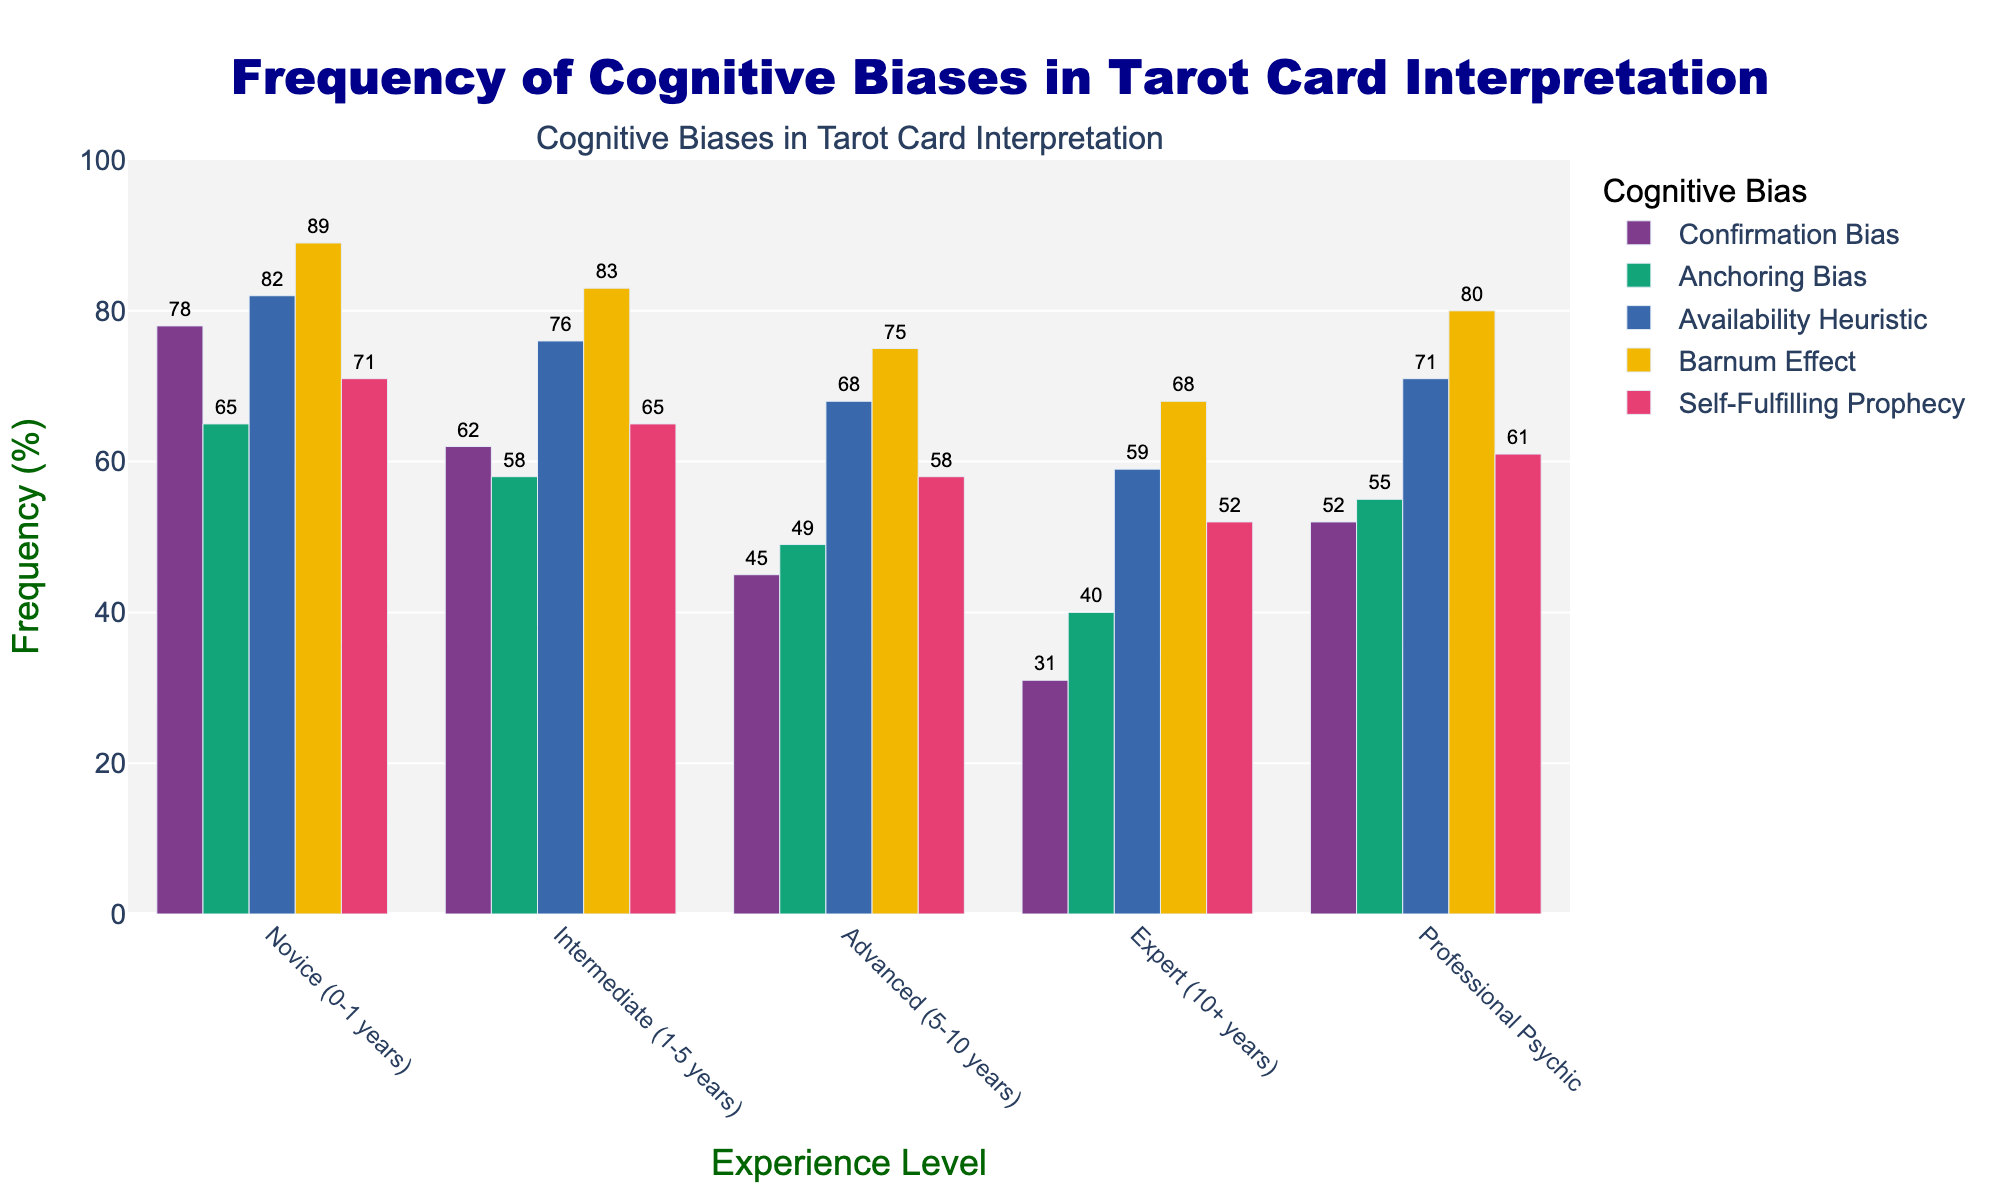Which experience level shows the highest frequency of the Barnum Effect? The height of the bars indicates the frequency; the Barnum Effect has the highest frequency bar for the "Novice (0-1 years)" group.
Answer: Novice (0-1 years) Which cognitive bias shows a decrease in frequency as the experience level of readers increases? By observing trends from Novice to Expert, all cognitive biases show a decrease. However, the decrease is most noticeable for Confirmation Bias and the Barnum Effect.
Answer: Confirmation Bias and Barnum Effect How much less frequent is the Anchoring Bias in Expert readers compared to Novice readers? Anchoring Bias frequency in Novice readers is 65 and in Expert readers is 40. The difference is 65 - 40.
Answer: 25 Which bias has the least variation in frequency across the different experience levels? By visually comparing the heights of the bars for each bias across experience levels, the Barnum Effect shows the smallest variance.
Answer: Barnum Effect What is the average frequency of the Availability Heuristic for all experience levels? Sum frequencies: (82+76+68+59+71)=356; average: 356/5=71.2
Answer: 71.2 On which cognitive bias do Novice readers and Professional Psychics have the most similar frequency, and what is the difference? By comparing the frequencies, the difference is least for Confirmation Bias (Novice: 78, Professional: 52, difference = 78 - 52 = 26) compared to other biases.
Answer: Confirmation Bias, 26 For intermediate readers, which cognitive bias has the highest frequency? For Intermediate (1-5 years), the highest bar is for the Barnum Effect at 83.
Answer: Barnum Effect Calculate the combined frequency of Self-Fulfilling Prophecy for Intermediate and Expert readers. Add frequencies: 65 (Intermediate) + 52 (Expert) = 117
Answer: 117 